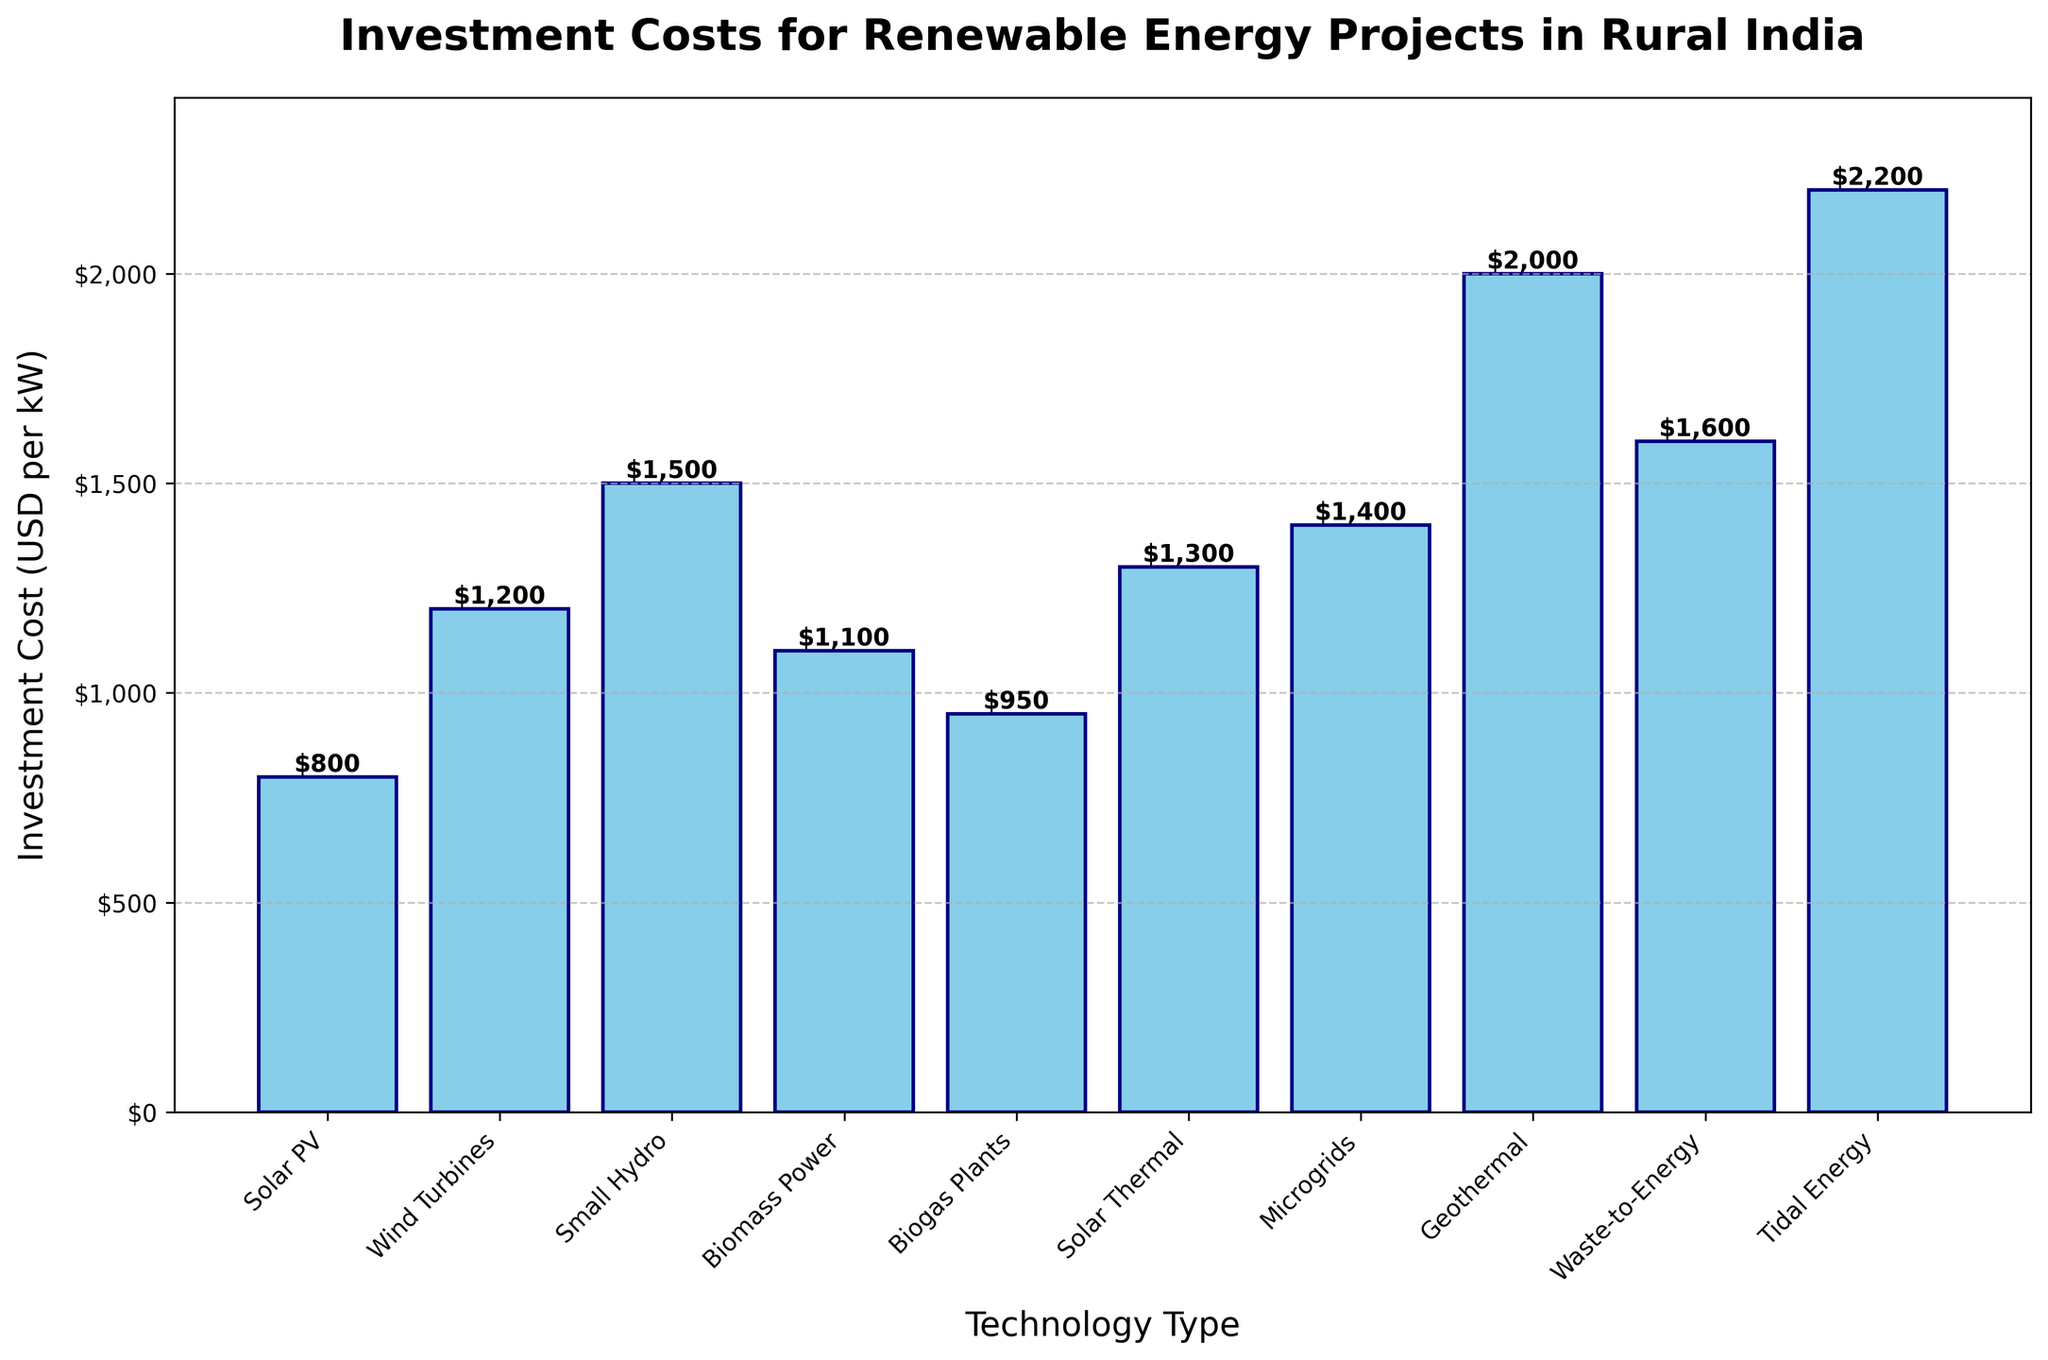What is the most expensive renewable energy technology in terms of investment cost per kW? The figure shows investment costs for various renewable energy technologies. Identify the bar with the highest value from the y-axis.
Answer: Tidal Energy Which technology has a lower investment cost per kW: Biomass Power or Biogas Plants? Compare the heights of the bars labeled "Biomass Power" and "Biogas Plants" in the chart.
Answer: Biogas Plants How much more expensive is Geothermal compared to Solar PV in terms of investment cost per kW? Look at the heights of the bars for Geothermal and Solar PV. Subtract Solar PV's investment cost from Geothermal's investment cost: $2000 - $800 = $1200.
Answer: $1200 What is the average investment cost per kW for Wind Turbines, Small Hydro, and Microgrids? Sum the investment costs for Wind Turbines, Small Hydro, and Microgrids: $1200 + $1500 + $1400 = $4100. Then divide by the number of technologies: $4100 / 3 = $1366.67.
Answer: $1366.67 Which technologies have an investment cost greater than $1300 per kW? Identify the bars with heights above $1300: Small Hydro, Microgrids, Geothermal, Waste-to-Energy, and Tidal Energy.
Answer: Small Hydro, Microgrids, Geothermal, Waste-to-Energy, Tidal Energy What is the total investment cost per kW for Solar Thermal and Waste-to-Energy combined? Add the investment costs for Solar Thermal and Waste-to-Energy: $1300 + $1600 = $2900.
Answer: $2900 Rank the following technologies from lowest to highest investment cost per kW: Solar PV, Wind Turbines, Biomass Power, and Biogas Plants. Compare the investment costs listed: Solar PV ($800), Wind Turbines ($1200), Biomass Power ($1100), Biogas Plants ($950). Rank them as follows: Solar PV, Biogas Plants, Biomass Power, Wind Turbines.
Answer: Solar PV, Biogas Plants, Biomass Power, Wind Turbines By how much does the investment in Tidal Energy exceed the investment in Small Hydro? Subtract the investment cost of Small Hydro from that of Tidal Energy: $2200 - $1500 = $700.
Answer: $700 What's the median investment cost per kW across all the renewable energy technologies listed? List the investment costs in ascending order: $800, $950, $1100, $1200, $1300, $1400, $1500, $1600, $2000, $2200. The median value is the middle number: ($1300 + $1400) / 2 = $1350.
Answer: $1350 